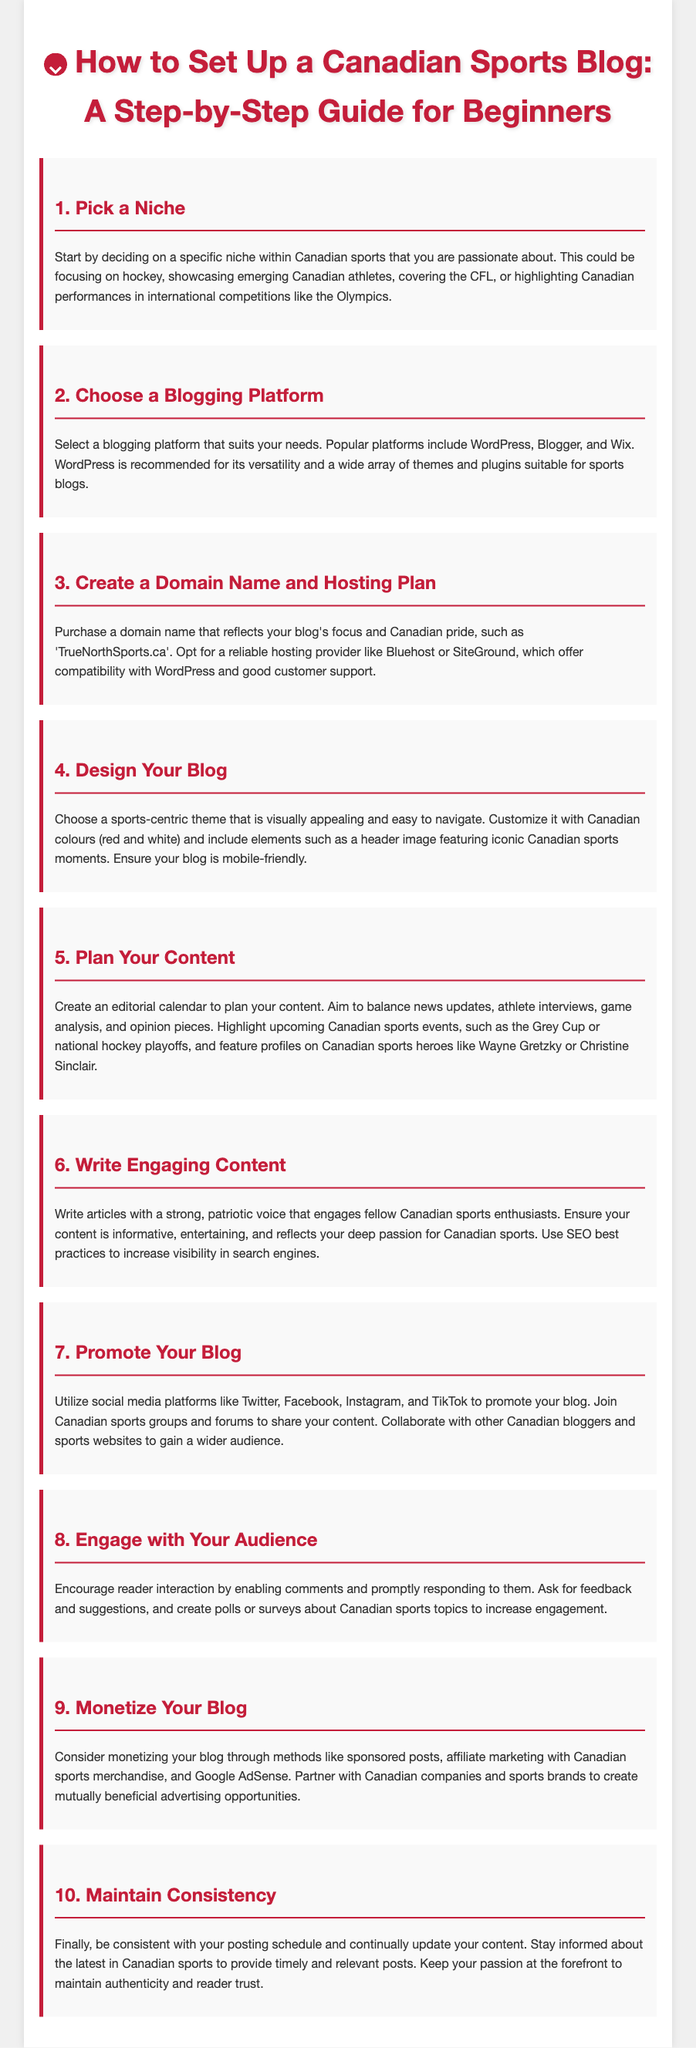What is the title of the guide? The title of the guide is "How to Set Up a Canadian Sports Blog: A Step-by-Step Guide for Beginners."
Answer: How to Set Up a Canadian Sports Blog: A Step-by-Step Guide for Beginners Which blogging platform is recommended in the guide? The guide recommends WordPress for its versatility and a wide array of themes and plugins suitable for sports blogs.
Answer: WordPress What is one way to promote your blog mentioned in the document? The document suggests utilizing social media platforms like Twitter, Facebook, Instagram, and TikTok for promoting your blog.
Answer: Social media platforms What color scheme is suggested for designing your blog? The guide recommends customizing the blog with Canadian colours (red and white).
Answer: Red and white How many steps are outlined in the guide? There are ten steps outlined in the guide for setting up a Canadian sports blog.
Answer: Ten steps What should you create to plan your content according to the guide? The guide advises creating an editorial calendar to plan your content effectively.
Answer: Editorial calendar What should be included in your blog's header image? The document suggests including iconic Canadian sports moments in the header image.
Answer: Iconic Canadian sports moments Which method of monetization is mentioned in the guide? Sponsored posts are mentioned as one of the methods to monetize your blog.
Answer: Sponsored posts What quality should your writing reflect according to the guide? The guide emphasizes that your writing should reflect a strong, patriotic voice.
Answer: Strong, patriotic voice 